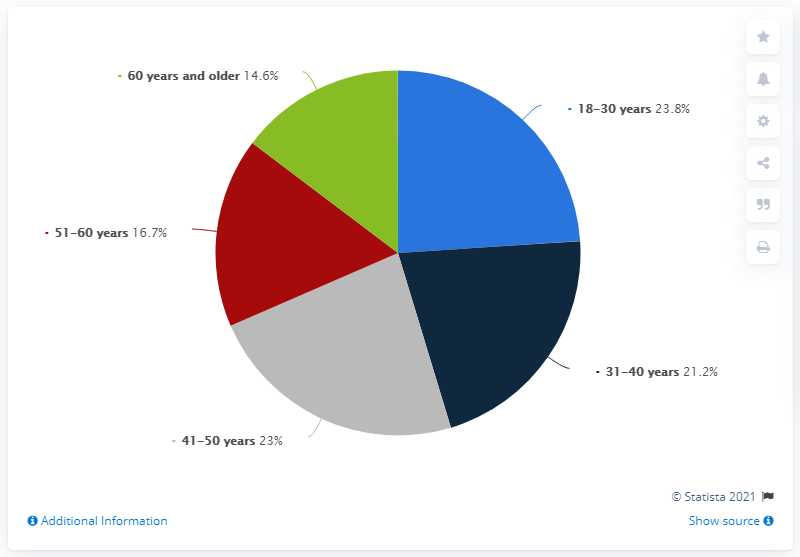What does the pie chart indicate about the age distribution of scam victims in Italy? The pie chart represents the age distribution of individuals who have been scammed in Italy. As per the chart, the majority of scams occur among those aged 41-50, accounting for 23% of the cases. The age group 18-30 years follows closely with 23.8%, then 31-40 years at 21.2%, 51-60 years at 16.7%, and lastly, those aged 60 years and older with 14.6% of the scams. 